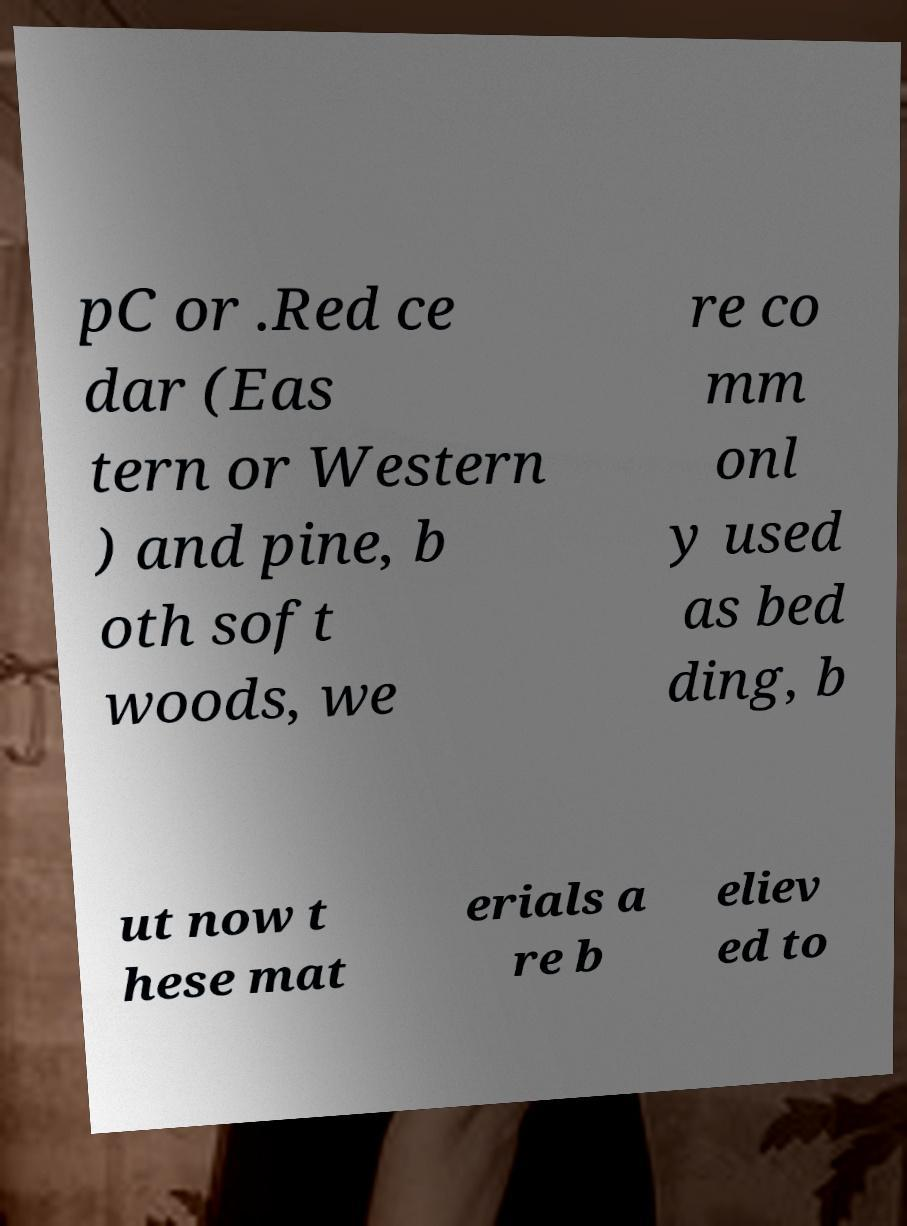Please identify and transcribe the text found in this image. pC or .Red ce dar (Eas tern or Western ) and pine, b oth soft woods, we re co mm onl y used as bed ding, b ut now t hese mat erials a re b eliev ed to 